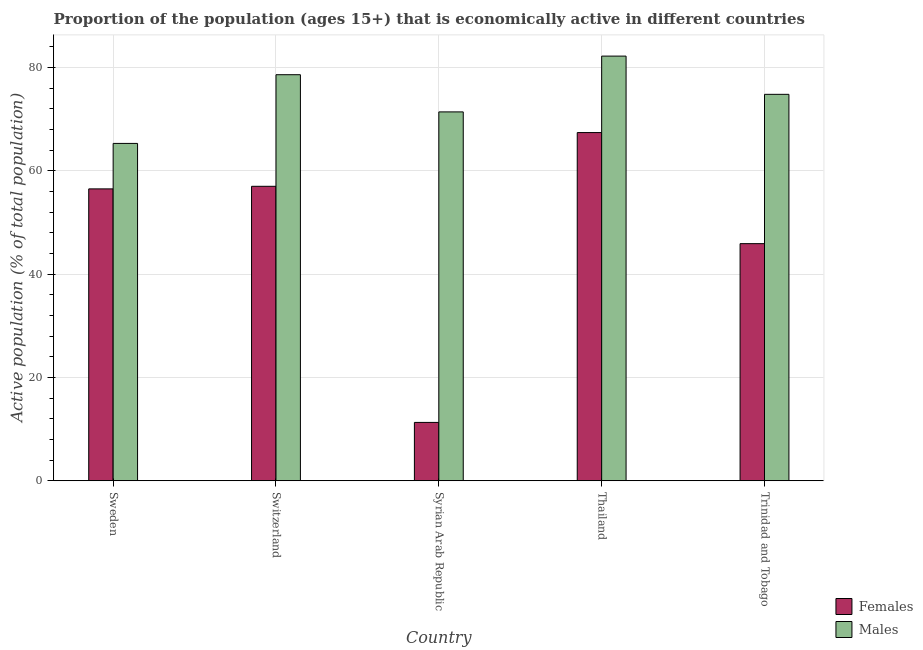How many different coloured bars are there?
Give a very brief answer. 2. How many groups of bars are there?
Offer a very short reply. 5. Are the number of bars per tick equal to the number of legend labels?
Provide a succinct answer. Yes. Are the number of bars on each tick of the X-axis equal?
Ensure brevity in your answer.  Yes. What is the label of the 2nd group of bars from the left?
Provide a succinct answer. Switzerland. In how many cases, is the number of bars for a given country not equal to the number of legend labels?
Offer a terse response. 0. What is the percentage of economically active female population in Sweden?
Provide a short and direct response. 56.5. Across all countries, what is the maximum percentage of economically active male population?
Your answer should be compact. 82.2. Across all countries, what is the minimum percentage of economically active male population?
Make the answer very short. 65.3. In which country was the percentage of economically active female population maximum?
Your answer should be very brief. Thailand. In which country was the percentage of economically active male population minimum?
Provide a succinct answer. Sweden. What is the total percentage of economically active male population in the graph?
Make the answer very short. 372.3. What is the difference between the percentage of economically active female population in Sweden and that in Syrian Arab Republic?
Provide a short and direct response. 45.2. What is the difference between the percentage of economically active male population in Thailand and the percentage of economically active female population in Sweden?
Your answer should be compact. 25.7. What is the average percentage of economically active female population per country?
Ensure brevity in your answer.  47.62. What is the difference between the percentage of economically active female population and percentage of economically active male population in Switzerland?
Keep it short and to the point. -21.6. In how many countries, is the percentage of economically active male population greater than 80 %?
Give a very brief answer. 1. What is the ratio of the percentage of economically active female population in Sweden to that in Switzerland?
Give a very brief answer. 0.99. Is the difference between the percentage of economically active male population in Sweden and Trinidad and Tobago greater than the difference between the percentage of economically active female population in Sweden and Trinidad and Tobago?
Offer a terse response. No. What is the difference between the highest and the second highest percentage of economically active male population?
Keep it short and to the point. 3.6. What is the difference between the highest and the lowest percentage of economically active male population?
Provide a short and direct response. 16.9. Is the sum of the percentage of economically active male population in Sweden and Syrian Arab Republic greater than the maximum percentage of economically active female population across all countries?
Provide a succinct answer. Yes. What does the 1st bar from the left in Thailand represents?
Your answer should be compact. Females. What does the 1st bar from the right in Trinidad and Tobago represents?
Your answer should be very brief. Males. Are the values on the major ticks of Y-axis written in scientific E-notation?
Make the answer very short. No. How many legend labels are there?
Your answer should be very brief. 2. How are the legend labels stacked?
Offer a very short reply. Vertical. What is the title of the graph?
Provide a succinct answer. Proportion of the population (ages 15+) that is economically active in different countries. Does "Female population" appear as one of the legend labels in the graph?
Ensure brevity in your answer.  No. What is the label or title of the Y-axis?
Keep it short and to the point. Active population (% of total population). What is the Active population (% of total population) in Females in Sweden?
Your answer should be very brief. 56.5. What is the Active population (% of total population) in Males in Sweden?
Provide a short and direct response. 65.3. What is the Active population (% of total population) in Males in Switzerland?
Keep it short and to the point. 78.6. What is the Active population (% of total population) of Females in Syrian Arab Republic?
Provide a succinct answer. 11.3. What is the Active population (% of total population) of Males in Syrian Arab Republic?
Ensure brevity in your answer.  71.4. What is the Active population (% of total population) in Females in Thailand?
Your answer should be very brief. 67.4. What is the Active population (% of total population) of Males in Thailand?
Make the answer very short. 82.2. What is the Active population (% of total population) of Females in Trinidad and Tobago?
Provide a short and direct response. 45.9. What is the Active population (% of total population) of Males in Trinidad and Tobago?
Provide a short and direct response. 74.8. Across all countries, what is the maximum Active population (% of total population) of Females?
Give a very brief answer. 67.4. Across all countries, what is the maximum Active population (% of total population) in Males?
Provide a succinct answer. 82.2. Across all countries, what is the minimum Active population (% of total population) in Females?
Offer a terse response. 11.3. Across all countries, what is the minimum Active population (% of total population) in Males?
Make the answer very short. 65.3. What is the total Active population (% of total population) of Females in the graph?
Offer a terse response. 238.1. What is the total Active population (% of total population) of Males in the graph?
Offer a terse response. 372.3. What is the difference between the Active population (% of total population) in Females in Sweden and that in Switzerland?
Your response must be concise. -0.5. What is the difference between the Active population (% of total population) of Females in Sweden and that in Syrian Arab Republic?
Make the answer very short. 45.2. What is the difference between the Active population (% of total population) in Males in Sweden and that in Syrian Arab Republic?
Provide a succinct answer. -6.1. What is the difference between the Active population (% of total population) in Males in Sweden and that in Thailand?
Provide a succinct answer. -16.9. What is the difference between the Active population (% of total population) in Females in Sweden and that in Trinidad and Tobago?
Offer a very short reply. 10.6. What is the difference between the Active population (% of total population) in Males in Sweden and that in Trinidad and Tobago?
Offer a terse response. -9.5. What is the difference between the Active population (% of total population) of Females in Switzerland and that in Syrian Arab Republic?
Offer a very short reply. 45.7. What is the difference between the Active population (% of total population) in Females in Switzerland and that in Thailand?
Provide a short and direct response. -10.4. What is the difference between the Active population (% of total population) in Males in Switzerland and that in Thailand?
Provide a succinct answer. -3.6. What is the difference between the Active population (% of total population) of Females in Switzerland and that in Trinidad and Tobago?
Offer a very short reply. 11.1. What is the difference between the Active population (% of total population) in Males in Switzerland and that in Trinidad and Tobago?
Ensure brevity in your answer.  3.8. What is the difference between the Active population (% of total population) of Females in Syrian Arab Republic and that in Thailand?
Your answer should be very brief. -56.1. What is the difference between the Active population (% of total population) of Females in Syrian Arab Republic and that in Trinidad and Tobago?
Your response must be concise. -34.6. What is the difference between the Active population (% of total population) in Males in Syrian Arab Republic and that in Trinidad and Tobago?
Your answer should be very brief. -3.4. What is the difference between the Active population (% of total population) in Females in Thailand and that in Trinidad and Tobago?
Ensure brevity in your answer.  21.5. What is the difference between the Active population (% of total population) in Females in Sweden and the Active population (% of total population) in Males in Switzerland?
Offer a very short reply. -22.1. What is the difference between the Active population (% of total population) of Females in Sweden and the Active population (% of total population) of Males in Syrian Arab Republic?
Keep it short and to the point. -14.9. What is the difference between the Active population (% of total population) of Females in Sweden and the Active population (% of total population) of Males in Thailand?
Make the answer very short. -25.7. What is the difference between the Active population (% of total population) of Females in Sweden and the Active population (% of total population) of Males in Trinidad and Tobago?
Keep it short and to the point. -18.3. What is the difference between the Active population (% of total population) in Females in Switzerland and the Active population (% of total population) in Males in Syrian Arab Republic?
Make the answer very short. -14.4. What is the difference between the Active population (% of total population) in Females in Switzerland and the Active population (% of total population) in Males in Thailand?
Your response must be concise. -25.2. What is the difference between the Active population (% of total population) of Females in Switzerland and the Active population (% of total population) of Males in Trinidad and Tobago?
Your answer should be compact. -17.8. What is the difference between the Active population (% of total population) in Females in Syrian Arab Republic and the Active population (% of total population) in Males in Thailand?
Provide a short and direct response. -70.9. What is the difference between the Active population (% of total population) in Females in Syrian Arab Republic and the Active population (% of total population) in Males in Trinidad and Tobago?
Ensure brevity in your answer.  -63.5. What is the average Active population (% of total population) of Females per country?
Provide a succinct answer. 47.62. What is the average Active population (% of total population) of Males per country?
Offer a terse response. 74.46. What is the difference between the Active population (% of total population) of Females and Active population (% of total population) of Males in Switzerland?
Offer a very short reply. -21.6. What is the difference between the Active population (% of total population) of Females and Active population (% of total population) of Males in Syrian Arab Republic?
Your answer should be compact. -60.1. What is the difference between the Active population (% of total population) in Females and Active population (% of total population) in Males in Thailand?
Make the answer very short. -14.8. What is the difference between the Active population (% of total population) of Females and Active population (% of total population) of Males in Trinidad and Tobago?
Your answer should be very brief. -28.9. What is the ratio of the Active population (% of total population) of Females in Sweden to that in Switzerland?
Offer a terse response. 0.99. What is the ratio of the Active population (% of total population) in Males in Sweden to that in Switzerland?
Make the answer very short. 0.83. What is the ratio of the Active population (% of total population) in Males in Sweden to that in Syrian Arab Republic?
Your response must be concise. 0.91. What is the ratio of the Active population (% of total population) in Females in Sweden to that in Thailand?
Keep it short and to the point. 0.84. What is the ratio of the Active population (% of total population) of Males in Sweden to that in Thailand?
Offer a very short reply. 0.79. What is the ratio of the Active population (% of total population) of Females in Sweden to that in Trinidad and Tobago?
Offer a very short reply. 1.23. What is the ratio of the Active population (% of total population) of Males in Sweden to that in Trinidad and Tobago?
Offer a terse response. 0.87. What is the ratio of the Active population (% of total population) of Females in Switzerland to that in Syrian Arab Republic?
Your answer should be very brief. 5.04. What is the ratio of the Active population (% of total population) of Males in Switzerland to that in Syrian Arab Republic?
Provide a succinct answer. 1.1. What is the ratio of the Active population (% of total population) in Females in Switzerland to that in Thailand?
Give a very brief answer. 0.85. What is the ratio of the Active population (% of total population) in Males in Switzerland to that in Thailand?
Your answer should be very brief. 0.96. What is the ratio of the Active population (% of total population) of Females in Switzerland to that in Trinidad and Tobago?
Make the answer very short. 1.24. What is the ratio of the Active population (% of total population) of Males in Switzerland to that in Trinidad and Tobago?
Your answer should be very brief. 1.05. What is the ratio of the Active population (% of total population) of Females in Syrian Arab Republic to that in Thailand?
Keep it short and to the point. 0.17. What is the ratio of the Active population (% of total population) of Males in Syrian Arab Republic to that in Thailand?
Offer a terse response. 0.87. What is the ratio of the Active population (% of total population) of Females in Syrian Arab Republic to that in Trinidad and Tobago?
Your answer should be very brief. 0.25. What is the ratio of the Active population (% of total population) in Males in Syrian Arab Republic to that in Trinidad and Tobago?
Give a very brief answer. 0.95. What is the ratio of the Active population (% of total population) in Females in Thailand to that in Trinidad and Tobago?
Keep it short and to the point. 1.47. What is the ratio of the Active population (% of total population) in Males in Thailand to that in Trinidad and Tobago?
Provide a short and direct response. 1.1. What is the difference between the highest and the second highest Active population (% of total population) of Females?
Your answer should be very brief. 10.4. What is the difference between the highest and the lowest Active population (% of total population) in Females?
Your response must be concise. 56.1. What is the difference between the highest and the lowest Active population (% of total population) in Males?
Make the answer very short. 16.9. 